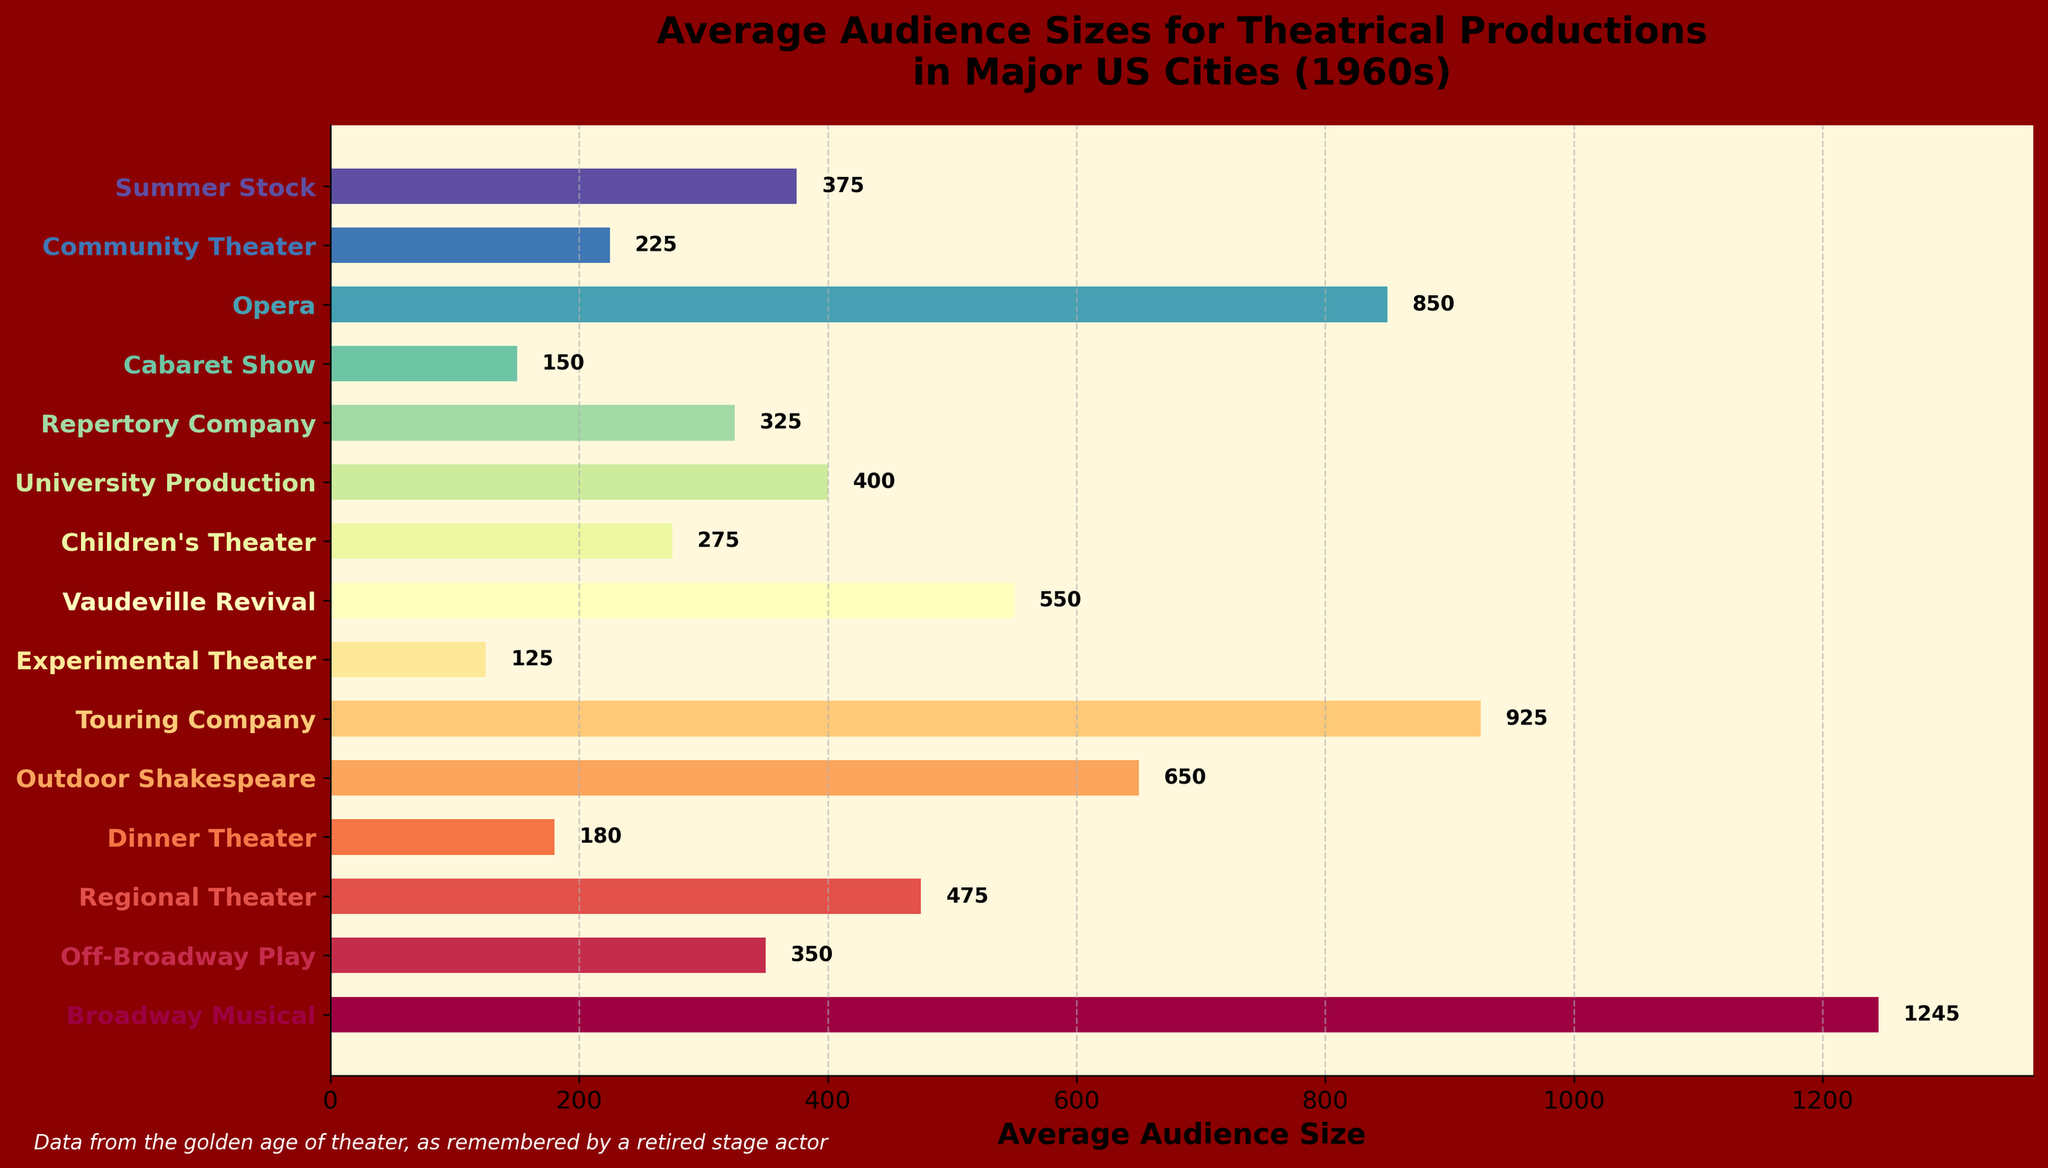What's the average audience size for Broadway Musical, Opera, and Touring Company combined? Combine the audience sizes: Broadway Musical (1245), Opera (850), and Touring Company (925). Add these values (1245 + 850 + 925 = 3020), then divide by 3 for the average (3020/3 ≈ 1006.67).
Answer: 1006.67 Which production type has the smallest average audience size? Looking at the chart, the production type with the smallest average audience size is Experimental Theater, with 125.
Answer: Experimental Theater How many production types have an average audience size greater than 500? Identify the bars with average audience sizes greater than 500: Broadway Musical, Outdoor Shakespeare, Touring Company, Opera, and Vaudeville Revival. Count these (5).
Answer: 5 What is the difference in average audience size between Broadway Musical and Off-Broadway Play? Subtract the average audience size of Off-Broadway Play (350) from that of Broadway Musical (1245). The difference is (1245 - 350 = 895).
Answer: 895 Which production type has about twice the average audience size of Community Theater? Community Theater has an average audience size of 225. The production type with about twice this size is Outdoor Shakespeare (225 * 2 ≈ 450, which is close to Outdoor Shakespeare's 650).
Answer: Outdoor Shakespeare What is the range of the average audience sizes for the production types? The range is the difference between the largest and smallest average audience sizes. Here, the largest is Broadway Musical (1245) and the smallest is Experimental Theater (125). The range is (1245 - 125 = 1120).
Answer: 1120 Which production type has a bar length about half that of the Touring Company? The Touring Company has an average audience size of 925. Half of this is about 462.5. The closest production type is Regional Theater with 475.
Answer: Regional Theater What color do the bars representing the highest and lowest average audience sizes have? Visually identifying, the bar for Broadway Musical (highest, 1245) is dark purple, and the bar for Experimental Theater (lowest, 125) is light green.
Answer: Dark purple, light green Arrange the production types with audience sizes greater than 500 in descending order. List production types with audience sizes greater than 500: Broadway Musical (1245), Touring Company (925), Opera (850), Outdoor Shakespeare (650), Vaudeville Revival (550). Arrange them in descending order: Broadway Musical, Touring Company, Opera, Outdoor Shakespeare, Vaudeville Revival.
Answer: Broadway Musical, Touring Company, Opera, Outdoor Shakespeare, Vaudeville Revival 